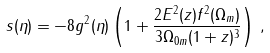<formula> <loc_0><loc_0><loc_500><loc_500>s ( \eta ) = - 8 g ^ { 2 } ( \eta ) \left ( 1 + \frac { 2 E ^ { 2 } ( z ) f ^ { 2 } ( \Omega _ { m } ) } { 3 \Omega _ { 0 m } ( 1 + z ) ^ { 3 } } \right ) \, ,</formula> 